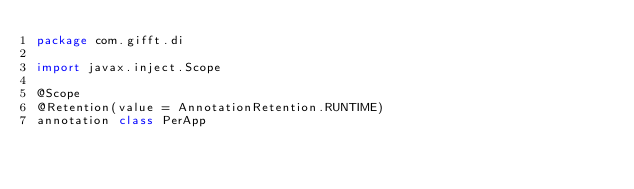<code> <loc_0><loc_0><loc_500><loc_500><_Kotlin_>package com.gifft.di

import javax.inject.Scope

@Scope
@Retention(value = AnnotationRetention.RUNTIME)
annotation class PerApp
</code> 